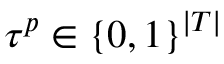<formula> <loc_0><loc_0><loc_500><loc_500>\tau ^ { p } \in \{ 0 , 1 \} ^ { | T | }</formula> 